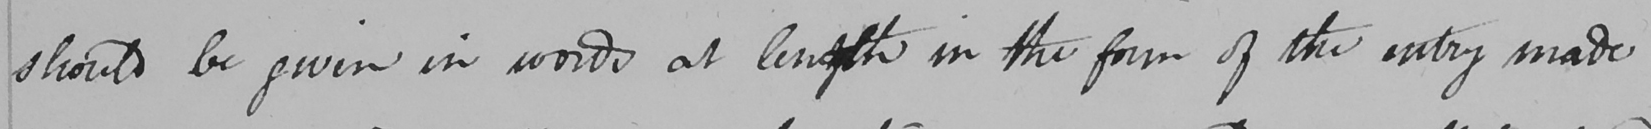Please transcribe the handwritten text in this image. should be given in words at length in the form of the entry made 